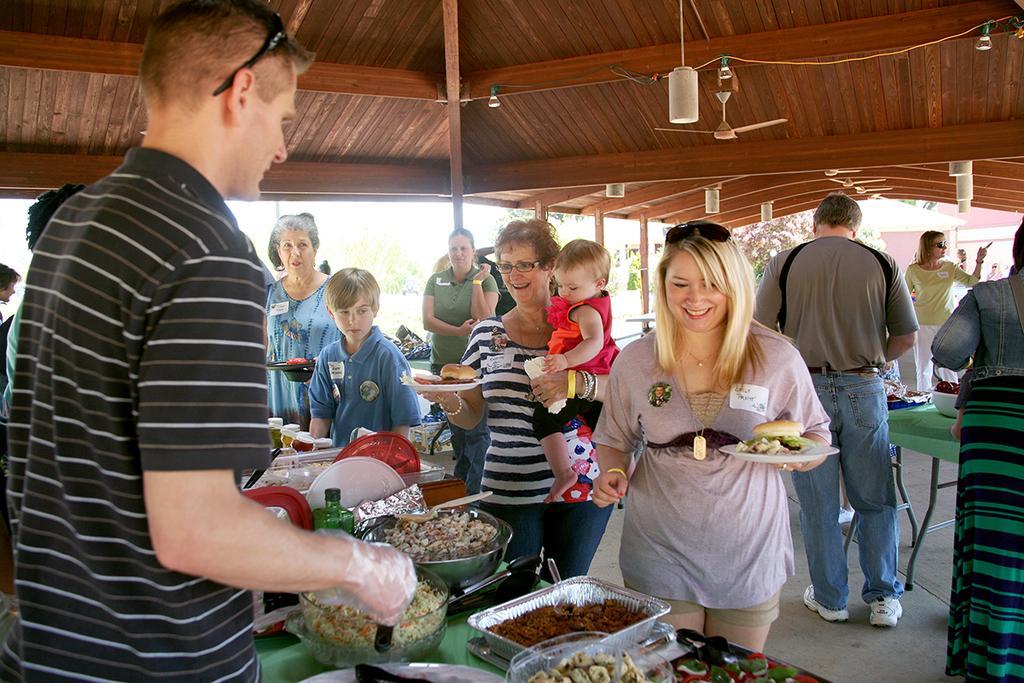Describe this image in one or two sentences. In this picture there is a man wearing black t-shirt, standing in the front and giving the food. In the front there is a woman standing in the front, smiling and taking the food in the plate. Behind there is an old woman holding a small girl in the hand and taking the food. Behind there are some women standing and looking them. On the top there is a wooden panel ceiling and some lights. 